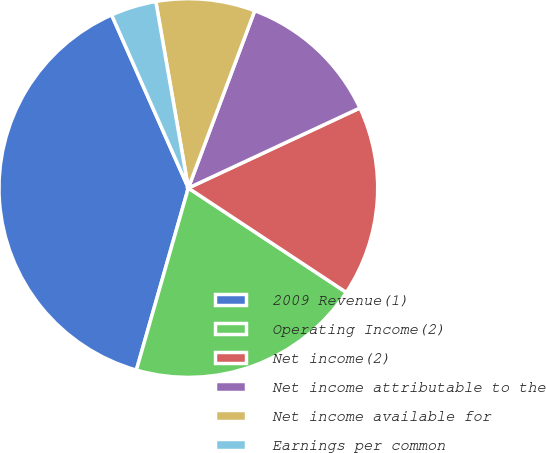Convert chart. <chart><loc_0><loc_0><loc_500><loc_500><pie_chart><fcel>2009 Revenue(1)<fcel>Operating Income(2)<fcel>Net income(2)<fcel>Net income attributable to the<fcel>Net income available for<fcel>Earnings per common<nl><fcel>38.93%<fcel>20.13%<fcel>16.24%<fcel>12.35%<fcel>8.45%<fcel>3.89%<nl></chart> 